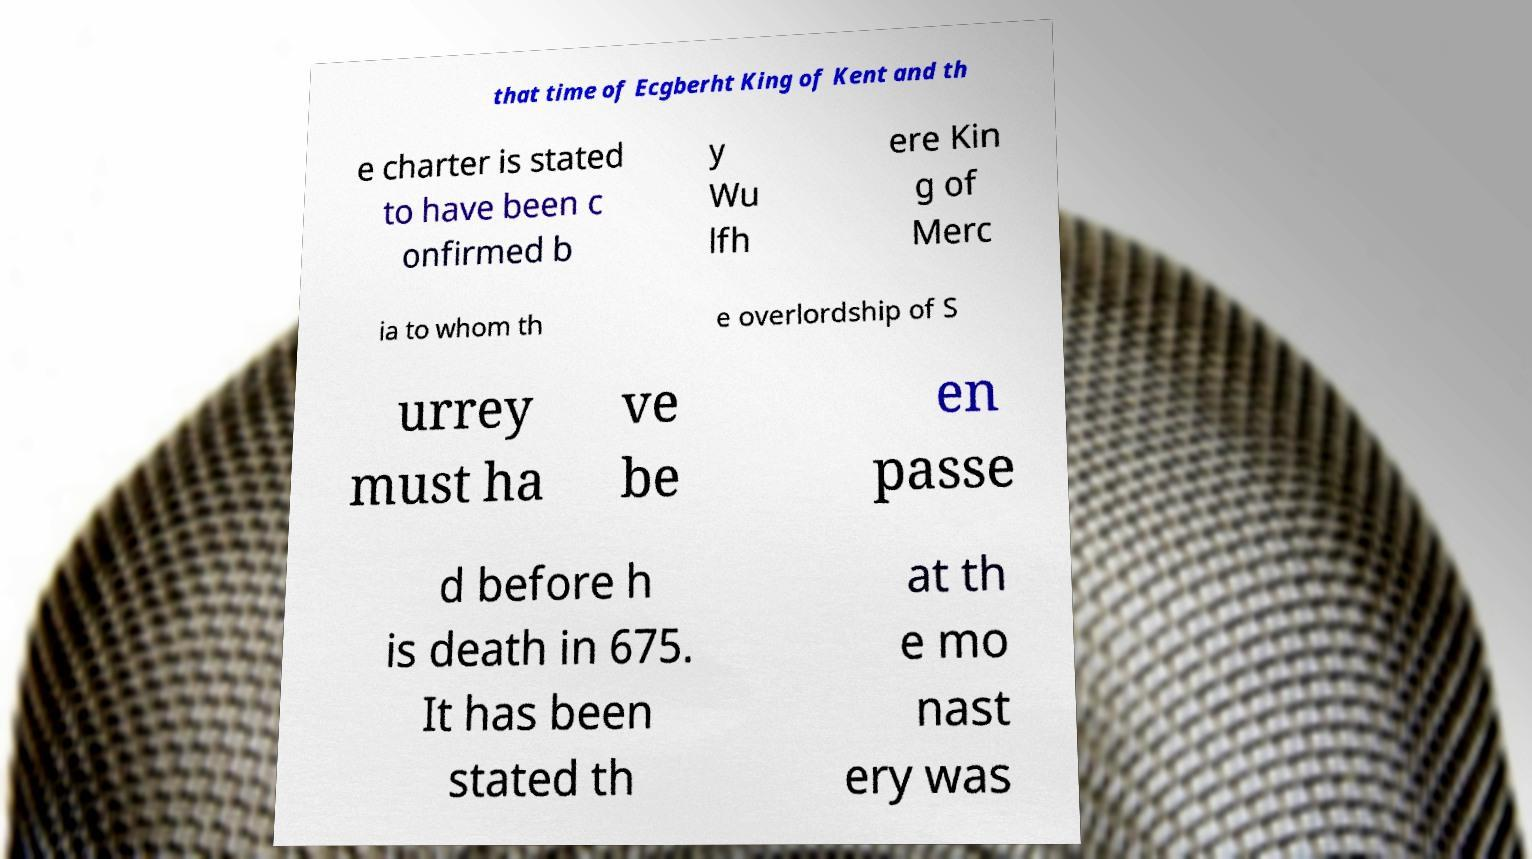Can you read and provide the text displayed in the image?This photo seems to have some interesting text. Can you extract and type it out for me? that time of Ecgberht King of Kent and th e charter is stated to have been c onfirmed b y Wu lfh ere Kin g of Merc ia to whom th e overlordship of S urrey must ha ve be en passe d before h is death in 675. It has been stated th at th e mo nast ery was 